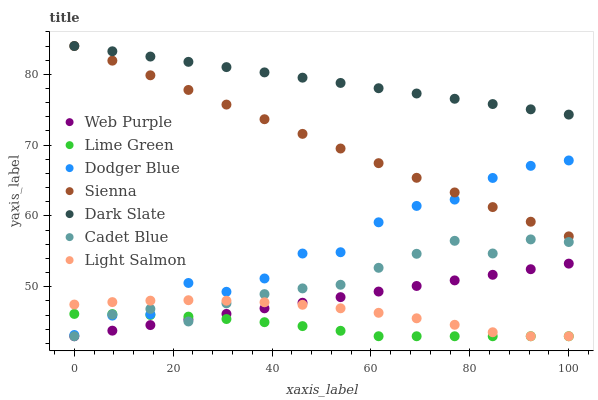Does Lime Green have the minimum area under the curve?
Answer yes or no. Yes. Does Dark Slate have the maximum area under the curve?
Answer yes or no. Yes. Does Cadet Blue have the minimum area under the curve?
Answer yes or no. No. Does Cadet Blue have the maximum area under the curve?
Answer yes or no. No. Is Web Purple the smoothest?
Answer yes or no. Yes. Is Dodger Blue the roughest?
Answer yes or no. Yes. Is Cadet Blue the smoothest?
Answer yes or no. No. Is Cadet Blue the roughest?
Answer yes or no. No. Does Light Salmon have the lowest value?
Answer yes or no. Yes. Does Sienna have the lowest value?
Answer yes or no. No. Does Dark Slate have the highest value?
Answer yes or no. Yes. Does Cadet Blue have the highest value?
Answer yes or no. No. Is Lime Green less than Sienna?
Answer yes or no. Yes. Is Sienna greater than Lime Green?
Answer yes or no. Yes. Does Dodger Blue intersect Light Salmon?
Answer yes or no. Yes. Is Dodger Blue less than Light Salmon?
Answer yes or no. No. Is Dodger Blue greater than Light Salmon?
Answer yes or no. No. Does Lime Green intersect Sienna?
Answer yes or no. No. 